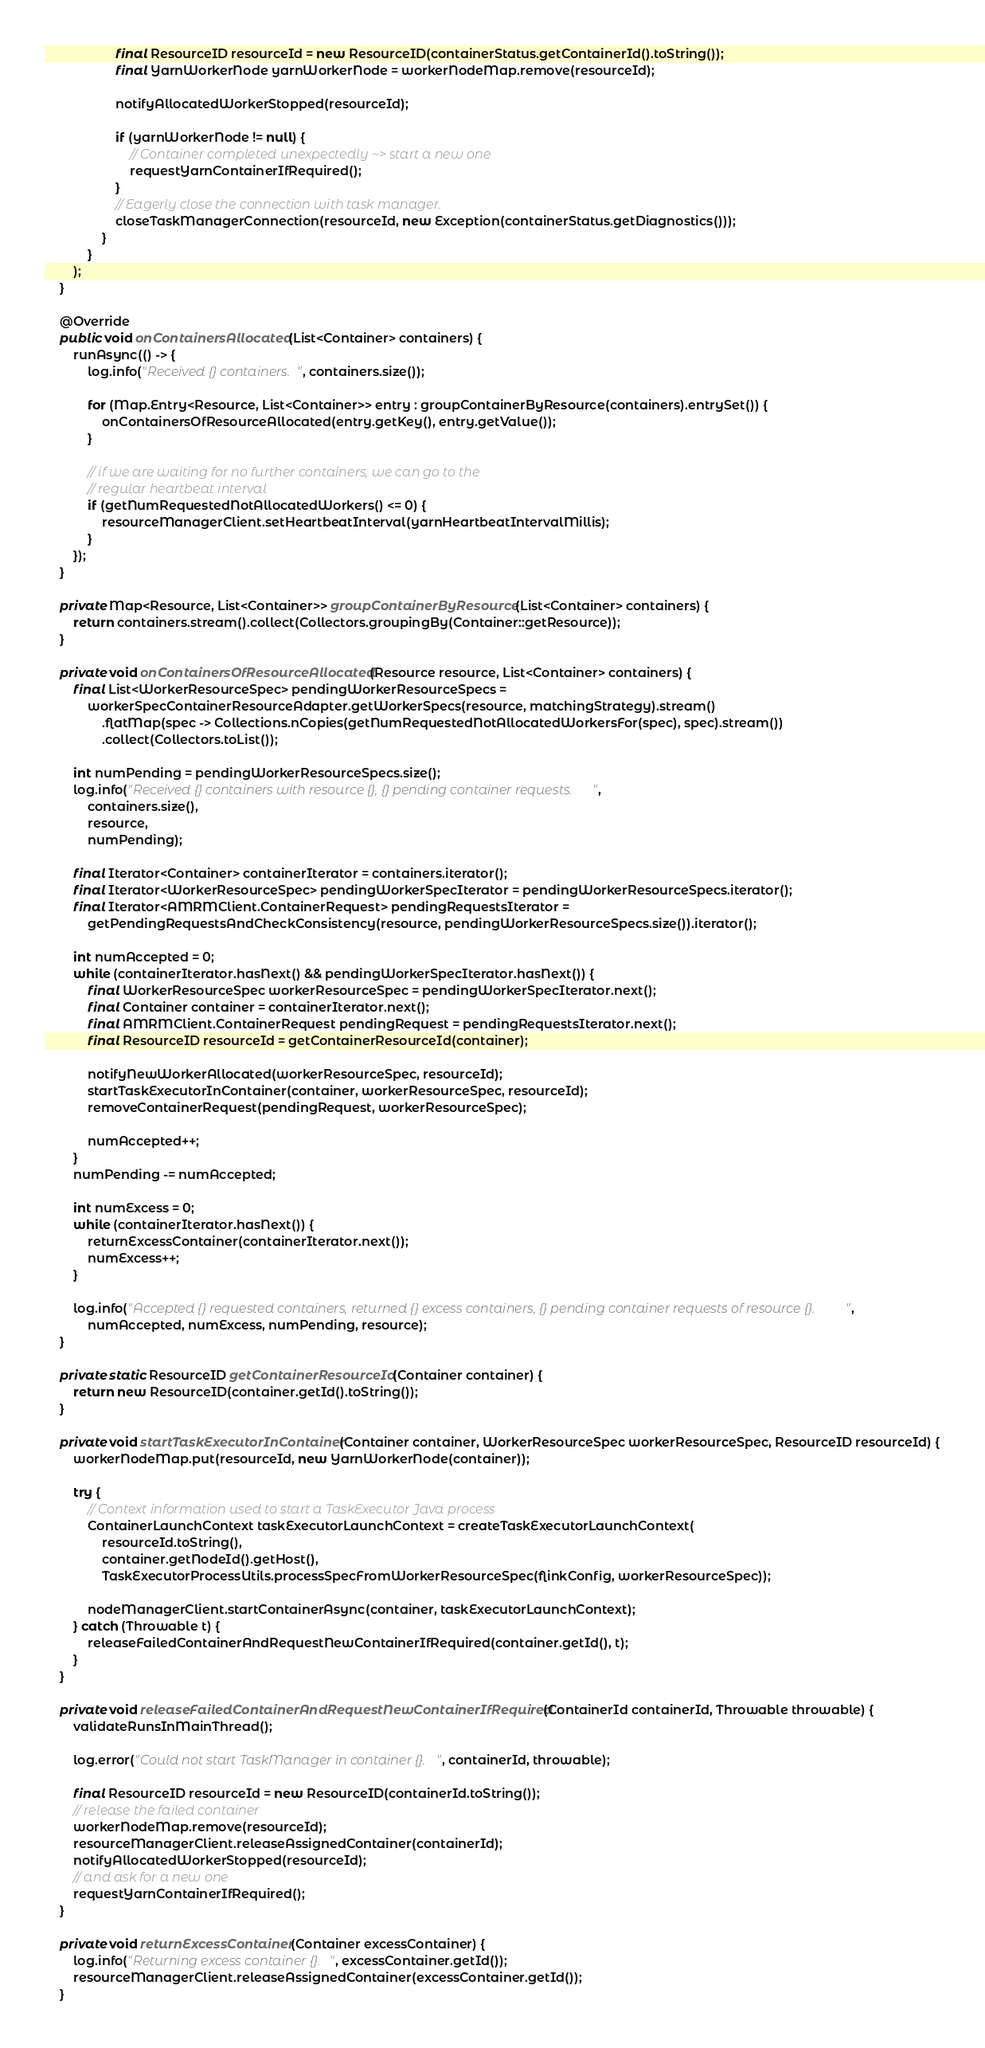<code> <loc_0><loc_0><loc_500><loc_500><_Java_>					final ResourceID resourceId = new ResourceID(containerStatus.getContainerId().toString());
					final YarnWorkerNode yarnWorkerNode = workerNodeMap.remove(resourceId);

					notifyAllocatedWorkerStopped(resourceId);

					if (yarnWorkerNode != null) {
						// Container completed unexpectedly ~> start a new one
						requestYarnContainerIfRequired();
					}
					// Eagerly close the connection with task manager.
					closeTaskManagerConnection(resourceId, new Exception(containerStatus.getDiagnostics()));
				}
			}
		);
	}

	@Override
	public void onContainersAllocated(List<Container> containers) {
		runAsync(() -> {
			log.info("Received {} containers.", containers.size());

			for (Map.Entry<Resource, List<Container>> entry : groupContainerByResource(containers).entrySet()) {
				onContainersOfResourceAllocated(entry.getKey(), entry.getValue());
			}

			// if we are waiting for no further containers, we can go to the
			// regular heartbeat interval
			if (getNumRequestedNotAllocatedWorkers() <= 0) {
				resourceManagerClient.setHeartbeatInterval(yarnHeartbeatIntervalMillis);
			}
		});
	}

	private Map<Resource, List<Container>> groupContainerByResource(List<Container> containers) {
		return containers.stream().collect(Collectors.groupingBy(Container::getResource));
	}

	private void onContainersOfResourceAllocated(Resource resource, List<Container> containers) {
		final List<WorkerResourceSpec> pendingWorkerResourceSpecs =
			workerSpecContainerResourceAdapter.getWorkerSpecs(resource, matchingStrategy).stream()
				.flatMap(spec -> Collections.nCopies(getNumRequestedNotAllocatedWorkersFor(spec), spec).stream())
				.collect(Collectors.toList());

		int numPending = pendingWorkerResourceSpecs.size();
		log.info("Received {} containers with resource {}, {} pending container requests.",
			containers.size(),
			resource,
			numPending);

		final Iterator<Container> containerIterator = containers.iterator();
		final Iterator<WorkerResourceSpec> pendingWorkerSpecIterator = pendingWorkerResourceSpecs.iterator();
		final Iterator<AMRMClient.ContainerRequest> pendingRequestsIterator =
			getPendingRequestsAndCheckConsistency(resource, pendingWorkerResourceSpecs.size()).iterator();

		int numAccepted = 0;
		while (containerIterator.hasNext() && pendingWorkerSpecIterator.hasNext()) {
			final WorkerResourceSpec workerResourceSpec = pendingWorkerSpecIterator.next();
			final Container container = containerIterator.next();
			final AMRMClient.ContainerRequest pendingRequest = pendingRequestsIterator.next();
			final ResourceID resourceId = getContainerResourceId(container);

			notifyNewWorkerAllocated(workerResourceSpec, resourceId);
			startTaskExecutorInContainer(container, workerResourceSpec, resourceId);
			removeContainerRequest(pendingRequest, workerResourceSpec);

			numAccepted++;
		}
		numPending -= numAccepted;

		int numExcess = 0;
		while (containerIterator.hasNext()) {
			returnExcessContainer(containerIterator.next());
			numExcess++;
		}

		log.info("Accepted {} requested containers, returned {} excess containers, {} pending container requests of resource {}.",
			numAccepted, numExcess, numPending, resource);
	}

	private static ResourceID getContainerResourceId(Container container) {
		return new ResourceID(container.getId().toString());
	}

	private void startTaskExecutorInContainer(Container container, WorkerResourceSpec workerResourceSpec, ResourceID resourceId) {
		workerNodeMap.put(resourceId, new YarnWorkerNode(container));

		try {
			// Context information used to start a TaskExecutor Java process
			ContainerLaunchContext taskExecutorLaunchContext = createTaskExecutorLaunchContext(
				resourceId.toString(),
				container.getNodeId().getHost(),
				TaskExecutorProcessUtils.processSpecFromWorkerResourceSpec(flinkConfig, workerResourceSpec));

			nodeManagerClient.startContainerAsync(container, taskExecutorLaunchContext);
		} catch (Throwable t) {
			releaseFailedContainerAndRequestNewContainerIfRequired(container.getId(), t);
		}
	}

	private void releaseFailedContainerAndRequestNewContainerIfRequired(ContainerId containerId, Throwable throwable) {
		validateRunsInMainThread();

		log.error("Could not start TaskManager in container {}.", containerId, throwable);

		final ResourceID resourceId = new ResourceID(containerId.toString());
		// release the failed container
		workerNodeMap.remove(resourceId);
		resourceManagerClient.releaseAssignedContainer(containerId);
		notifyAllocatedWorkerStopped(resourceId);
		// and ask for a new one
		requestYarnContainerIfRequired();
	}

	private void returnExcessContainer(Container excessContainer) {
		log.info("Returning excess container {}.", excessContainer.getId());
		resourceManagerClient.releaseAssignedContainer(excessContainer.getId());
	}
</code> 